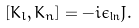<formula> <loc_0><loc_0><loc_500><loc_500>[ K _ { l } , K _ { n } ] = - i \epsilon _ { \ln } J .</formula> 